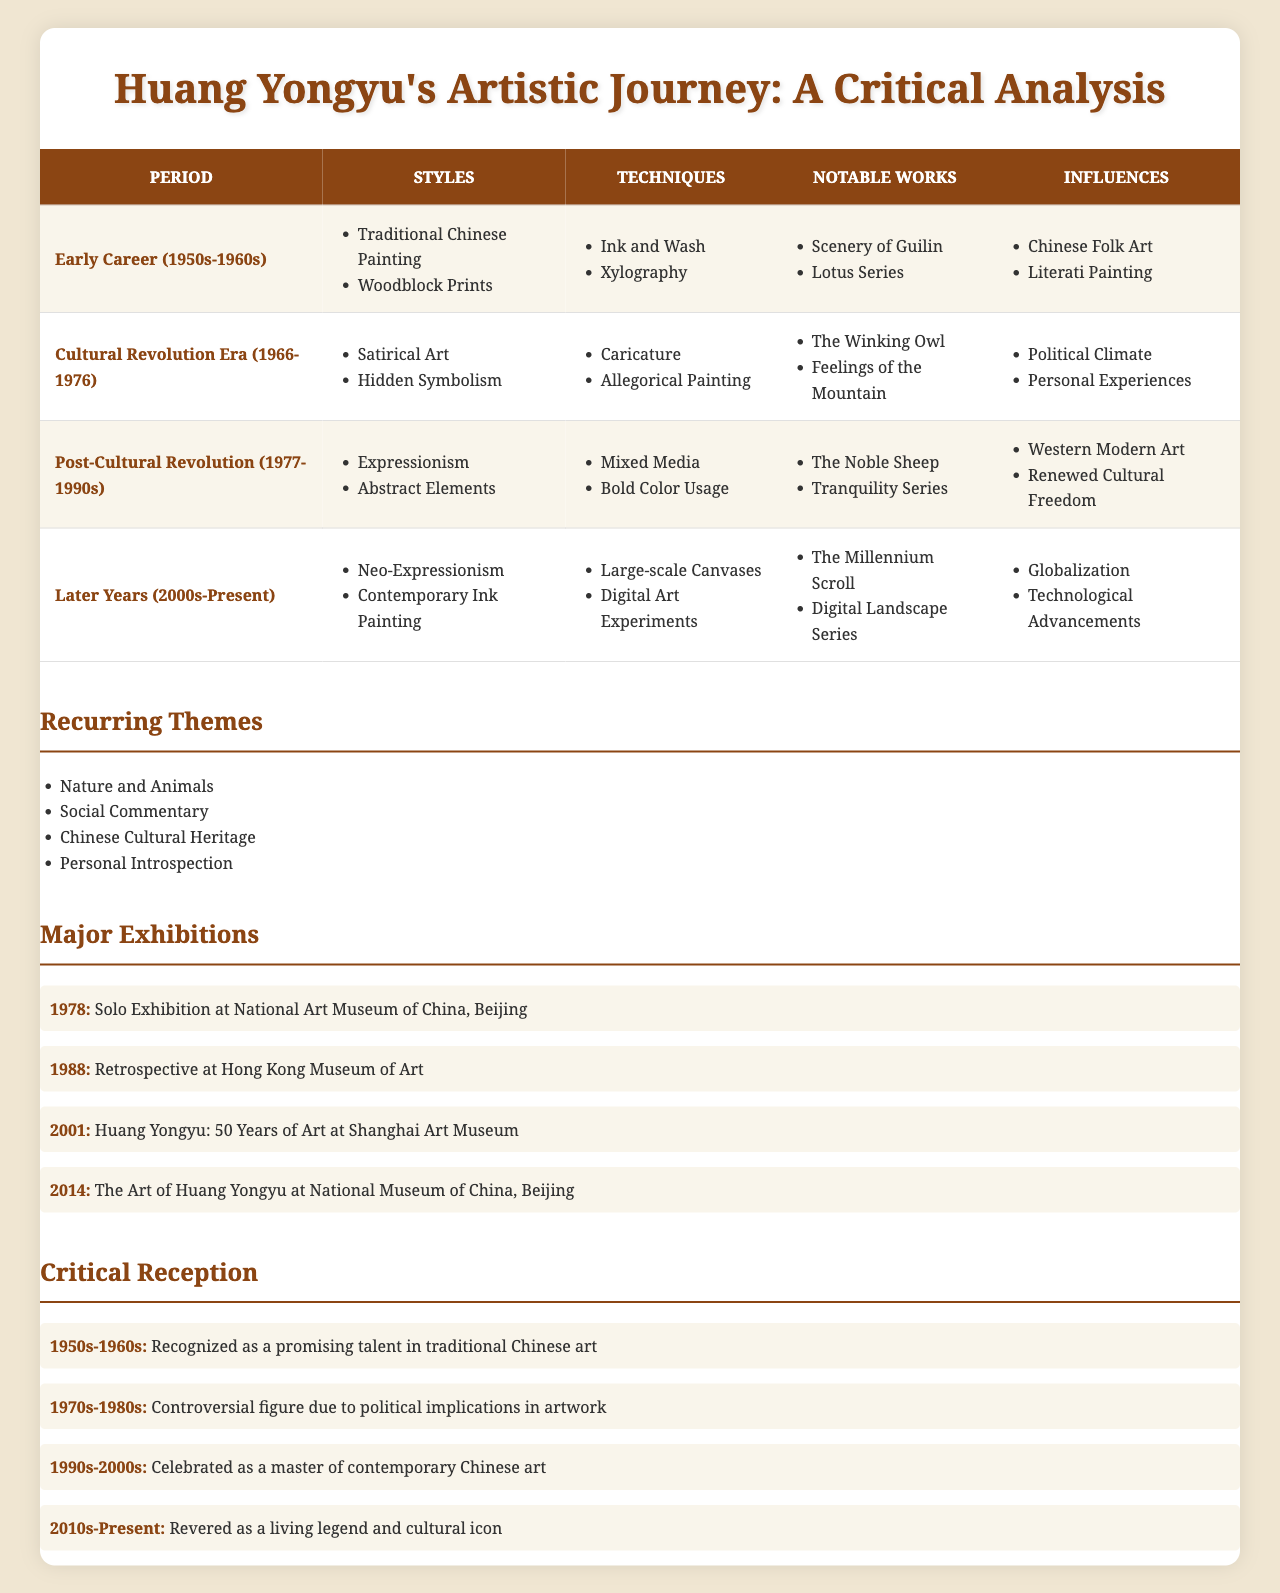What artistic styles were prominent during Huang Yongyu's early career? In the table, under the "Early Career (1950s-1960s)" period, the styles listed are "Traditional Chinese Painting" and "Woodblock Prints."
Answer: Traditional Chinese Painting, Woodblock Prints Which technique was used by Huang during the Cultural Revolution Era? Referring to the table for the "Cultural Revolution Era (1966-1976)," the techniques mentioned are "Caricature" and "Allegorical Painting."
Answer: Caricature, Allegorical Painting What were Huang Yongyu's notable works in his later years? In the "Later Years (2000s-Present)" section, the notable works listed are "The Millennium Scroll" and "Digital Landscape Series."
Answer: The Millennium Scroll, Digital Landscape Series How many major exhibitions are noted for Huang Yongyu and what was the year of the retrospective? The table lists four major exhibitions. The retrospective year is 1988, as stated in the "Major Exhibitions" section.
Answer: 4 exhibitions; retrospective in 1988 What influence is noted in Huang Yongyu's post-Cultural Revolution works? The influences during the "Post-Cultural Revolution (1977-1990s)" period are "Western Modern Art" and "Renewed Cultural Freedom," according to the table.
Answer: Western Modern Art, Renewed Cultural Freedom Which period had the most critical reception as a "living legend and cultural icon"? According to the "Critical Reception" section, it states that during the "2010s-Present" period, Huang is regarded as a "living legend and cultural icon."
Answer: 2010s-Present Did Huang Yongyu explore digital art in his later years? Yes, the table mentions "Digital Art Experiments" as one of the techniques during the "Later Years (2000s-Present)."
Answer: Yes What unique themes recurred in Huang Yongyu's artistic work? The recurring themes include "Nature and Animals," "Social Commentary," "Chinese Cultural Heritage," and "Personal Introspection," as listed in the table.
Answer: Nature and Animals, Social Commentary, Chinese Cultural Heritage, Personal Introspection What notable works characterize Huang Yongyu's expressionist phase? The "Notable Works" during the "Post-Cultural Revolution (1977-1990s)" phase include "The Noble Sheep" and "Tranquility Series."
Answer: The Noble Sheep, Tranquility Series How many periods included influences from "Chinese Folk Art"? The "Early Career (1950s-1960s)" period includes "Chinese Folk Art" as an influence, so there is one distinct period noted for this influence.
Answer: 1 period 